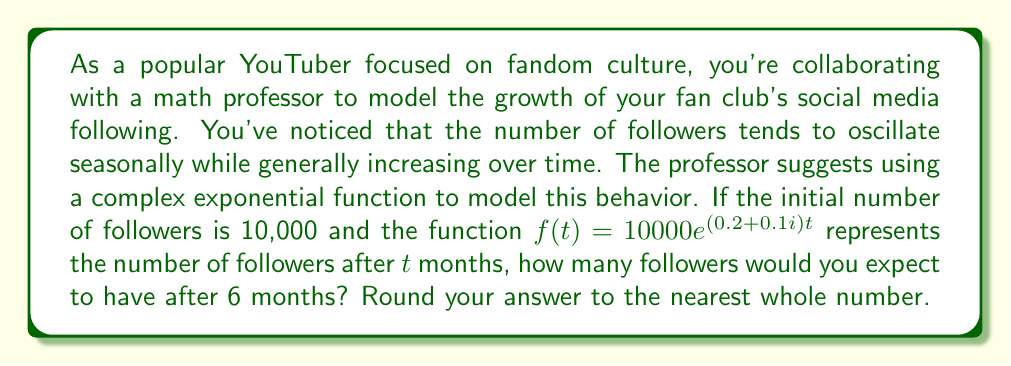Show me your answer to this math problem. Let's approach this step-by-step:

1) We're given the function $f(t) = 10000e^{(0.2 + 0.1i)t}$, where $t$ is time in months.

2) We need to evaluate this function at $t = 6$.

3) Let's substitute $t = 6$ into the function:

   $f(6) = 10000e^{(0.2 + 0.1i)6}$

4) Simplify the exponent:
   
   $f(6) = 10000e^{1.2 + 0.6i}$

5) To evaluate this, we can use Euler's formula: $e^{a+bi} = e^a(\cos b + i\sin b)$

6) In our case, $a = 1.2$ and $b = 0.6$:

   $f(6) = 10000e^{1.2}(\cos 0.6 + i\sin 0.6)$

7) Let's evaluate each part:
   
   $e^{1.2} \approx 3.3201$
   $\cos 0.6 \approx 0.8253$
   $\sin 0.6 \approx 0.5646$

8) Substituting these values:

   $f(6) \approx 10000 \cdot 3.3201 \cdot (0.8253 + 0.5646i)$

9) Multiply:

   $f(6) \approx 33201 \cdot (0.8253 + 0.5646i)$
   $f(6) \approx 27401 + 18746i$

10) The magnitude of this complex number represents the actual number of followers:

    $|f(6)| = \sqrt{27401^2 + 18746^2} \approx 33201$

11) Rounding to the nearest whole number:

    $|f(6)| \approx 33201$
Answer: 33201 followers 